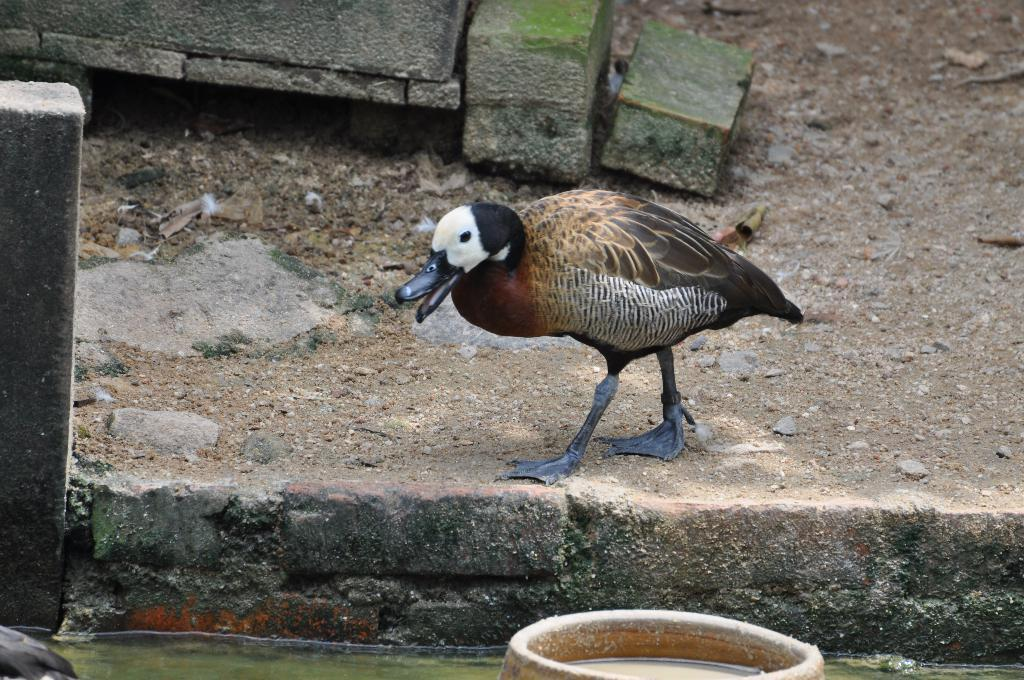What type of animal can be seen in the image? A: There is a bird in the image. Can you describe the bird's coloring? The bird has black, white, and brown coloring. What type of surface is visible in the image? There is ground visible in the image. What can be found on the ground in the image? There are stones on the ground in the image. What else is visible in the image besides the bird and the ground? There is water visible in the image. What type of bells can be heard ringing in the image? There are no bells present in the image, and therefore no sound can be heard. 